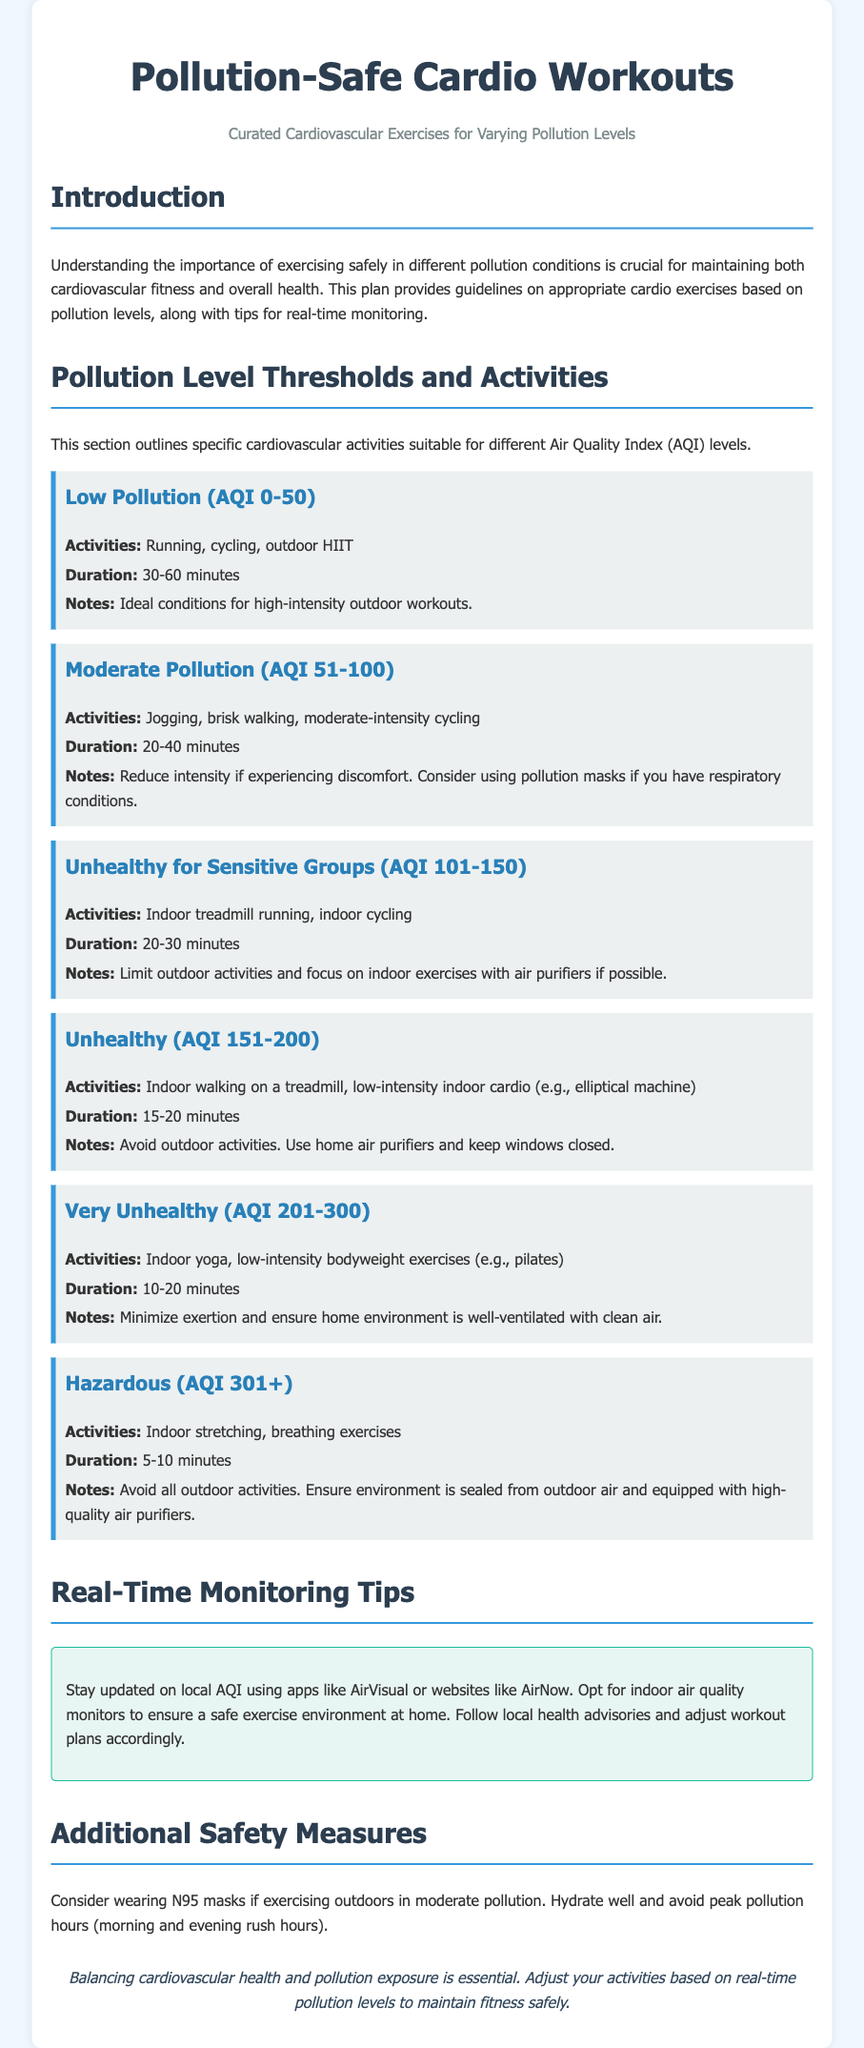what is the title of the document? The title of the document is stated in the header and provides the main subject matter of the content.
Answer: Pollution-Safe Cardio Workouts what is the subtitle of the document? The subtitle gives more context about the main theme of the workouts outlined in the document.
Answer: Curated Cardiovascular Exercises for Varying Pollution Levels what activities are suggested for low pollution conditions? The activities are specified under the pollution level threshold for low pollution, indicating what exercises are appropriate.
Answer: Running, cycling, outdoor HIIT what is the AQI range for moderate pollution? The range specifies the classification of air quality, which influences the recommended activities.
Answer: 51-100 how long should you exercise under unhealthy conditions? The document outlines the recommended duration of exercise for unhealthy air quality levels to ensure safety.
Answer: 15-20 minutes what type of exercises are recommended during hazardous pollution conditions? The exercises outlined reflect what is appropriate when pollution levels reach hazardous thresholds, emphasizing safety.
Answer: Indoor stretching, breathing exercises how can one monitor real-time air quality? The document provides guidance on methods to stay informed about air pollution levels for safe exercise planning.
Answer: Apps like AirVisual or websites like AirNow what additional safety measure is suggested for outdoor exercise in moderate pollution? The document suggests certain precautions to take when exercising outdoors under specific pollution levels for safety.
Answer: Wearing N95 masks what is the conclusion of the document? The conclusion summarizes the main message of the document, reinforcing the importance of safety measures in exercising amidst pollution.
Answer: Balancing cardiovascular health and pollution exposure is essential 